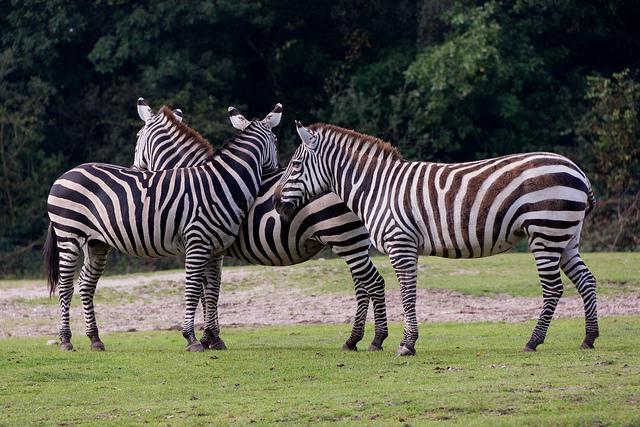How many zebras are there?
Give a very brief answer. 3. How many animals are in this picture?
Give a very brief answer. 3. How many zebras are visible?
Give a very brief answer. 3. How many zebras are here?
Give a very brief answer. 3. How many people are in the park?
Give a very brief answer. 0. 